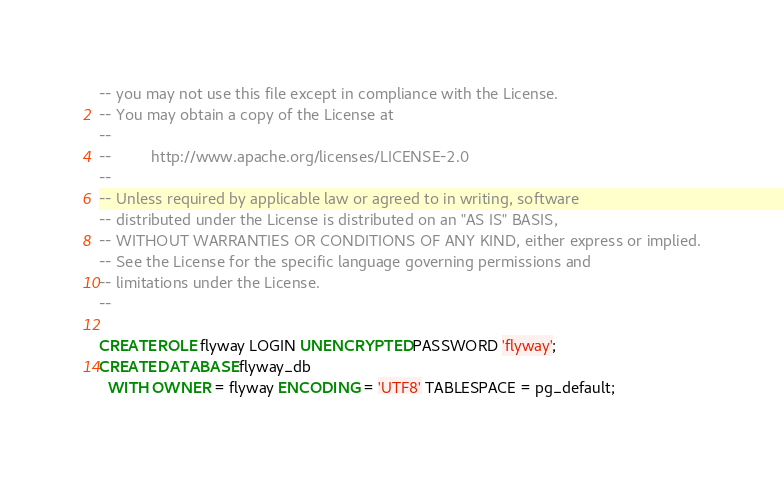Convert code to text. <code><loc_0><loc_0><loc_500><loc_500><_SQL_>-- you may not use this file except in compliance with the License.
-- You may obtain a copy of the License at
--
--         http://www.apache.org/licenses/LICENSE-2.0
--
-- Unless required by applicable law or agreed to in writing, software
-- distributed under the License is distributed on an "AS IS" BASIS,
-- WITHOUT WARRANTIES OR CONDITIONS OF ANY KIND, either express or implied.
-- See the License for the specific language governing permissions and
-- limitations under the License.
--

CREATE ROLE flyway LOGIN UNENCRYPTED PASSWORD 'flyway';
CREATE DATABASE flyway_db
  WITH OWNER = flyway ENCODING = 'UTF8' TABLESPACE = pg_default;
</code> 